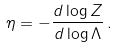<formula> <loc_0><loc_0><loc_500><loc_500>\eta = - \frac { d \log Z } { d \log \Lambda } \, .</formula> 